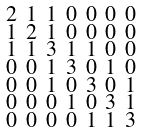Convert formula to latex. <formula><loc_0><loc_0><loc_500><loc_500>\begin{smallmatrix} 2 & 1 & 1 & 0 & 0 & 0 & 0 \\ 1 & 2 & 1 & 0 & 0 & 0 & 0 \\ 1 & 1 & 3 & 1 & 1 & 0 & 0 \\ 0 & 0 & 1 & 3 & 0 & 1 & 0 \\ 0 & 0 & 1 & 0 & 3 & 0 & 1 \\ 0 & 0 & 0 & 1 & 0 & 3 & 1 \\ 0 & 0 & 0 & 0 & 1 & 1 & 3 \end{smallmatrix}</formula> 